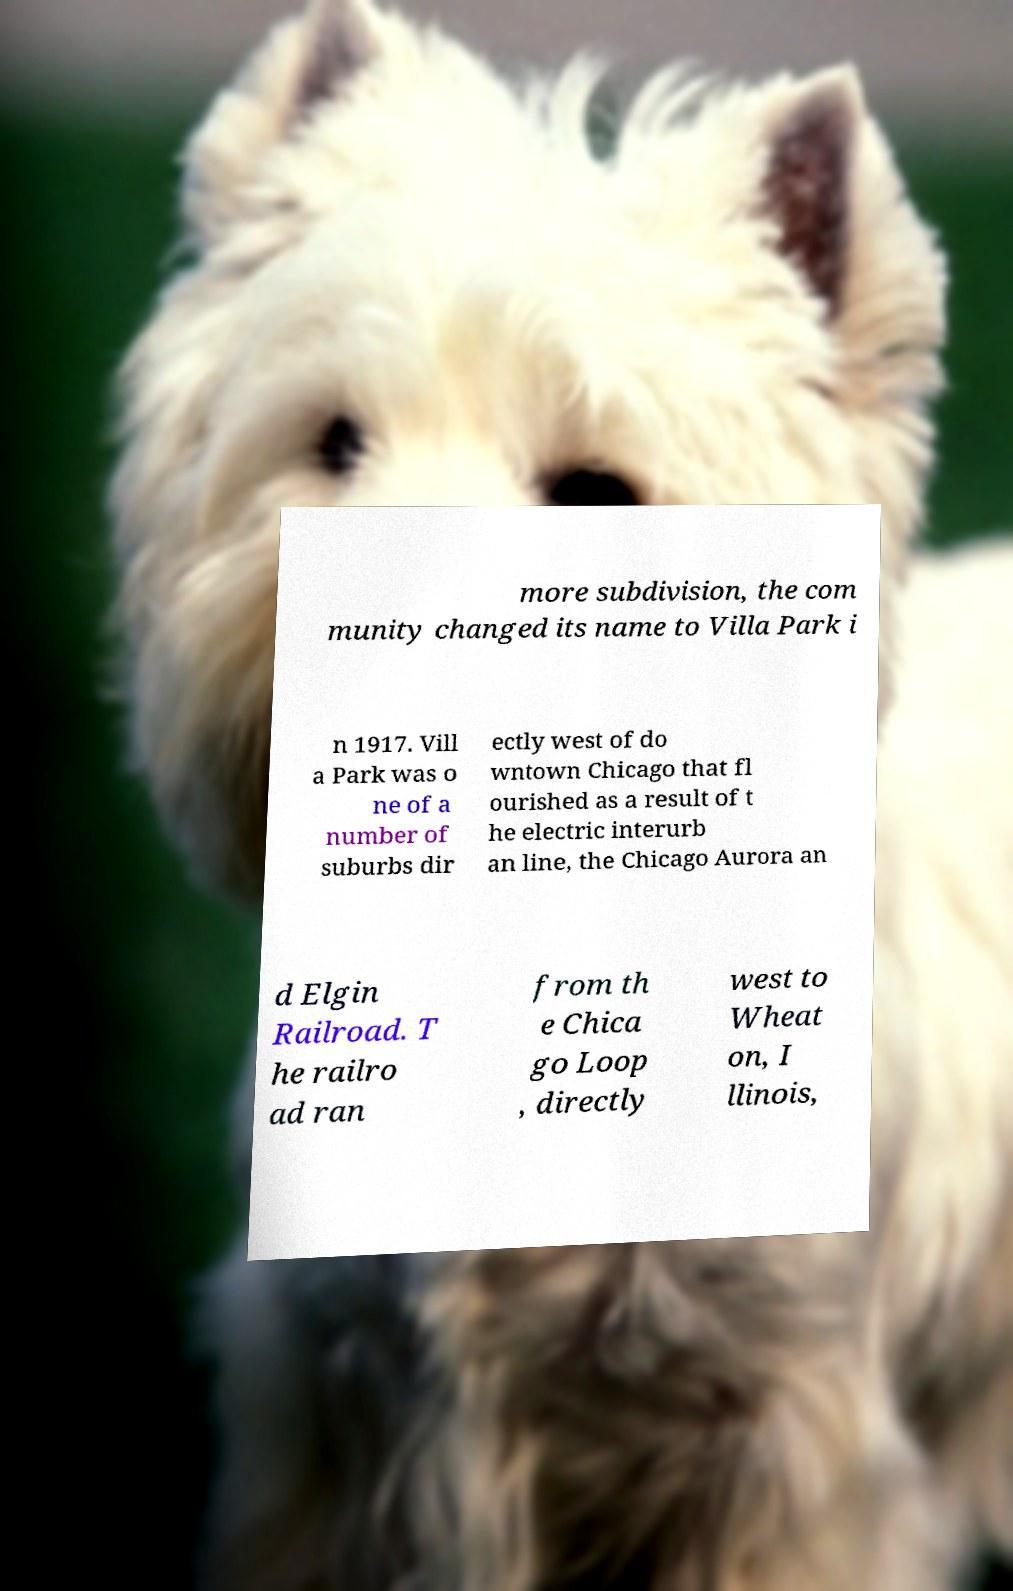Can you read and provide the text displayed in the image?This photo seems to have some interesting text. Can you extract and type it out for me? more subdivision, the com munity changed its name to Villa Park i n 1917. Vill a Park was o ne of a number of suburbs dir ectly west of do wntown Chicago that fl ourished as a result of t he electric interurb an line, the Chicago Aurora an d Elgin Railroad. T he railro ad ran from th e Chica go Loop , directly west to Wheat on, I llinois, 